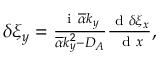Convert formula to latex. <formula><loc_0><loc_0><loc_500><loc_500>\begin{array} { r } { \delta \xi _ { y } = \frac { i \overline { \alpha } k _ { y } } { \overline { \alpha } k _ { y } ^ { 2 } - D _ { A } } \frac { d \delta \xi _ { x } } { d x } , } \end{array}</formula> 